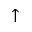Convert formula to latex. <formula><loc_0><loc_0><loc_500><loc_500>\uparrow</formula> 